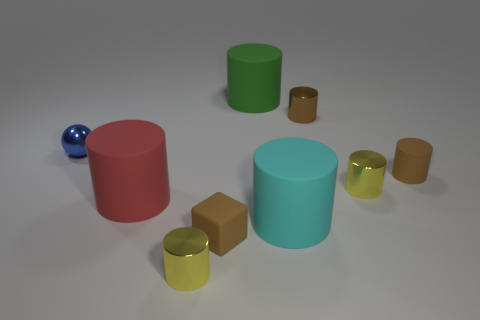Do the small blue ball and the yellow cylinder that is in front of the tiny matte block have the same material?
Offer a very short reply. Yes. How many other things are there of the same shape as the tiny blue metal thing?
Your answer should be very brief. 0. How many objects are either big rubber objects to the left of the cube or objects in front of the green rubber thing?
Your answer should be compact. 8. How many other objects are there of the same color as the tiny rubber cube?
Offer a very short reply. 2. Is the number of cubes in front of the cyan matte cylinder less than the number of blue things behind the green matte cylinder?
Provide a short and direct response. No. What number of metallic spheres are there?
Your answer should be compact. 1. Are there any other things that are the same material as the large cyan cylinder?
Provide a short and direct response. Yes. What material is the big red object that is the same shape as the green object?
Ensure brevity in your answer.  Rubber. Are there fewer small brown matte cylinders on the right side of the small rubber cylinder than brown cylinders?
Provide a succinct answer. Yes. There is a small metallic object behind the tiny metallic sphere; is its shape the same as the tiny blue object?
Give a very brief answer. No. 